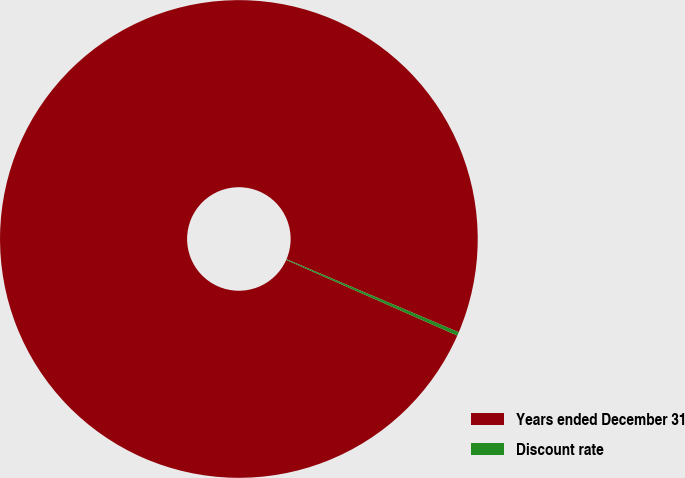Convert chart to OTSL. <chart><loc_0><loc_0><loc_500><loc_500><pie_chart><fcel>Years ended December 31<fcel>Discount rate<nl><fcel>99.76%<fcel>0.24%<nl></chart> 